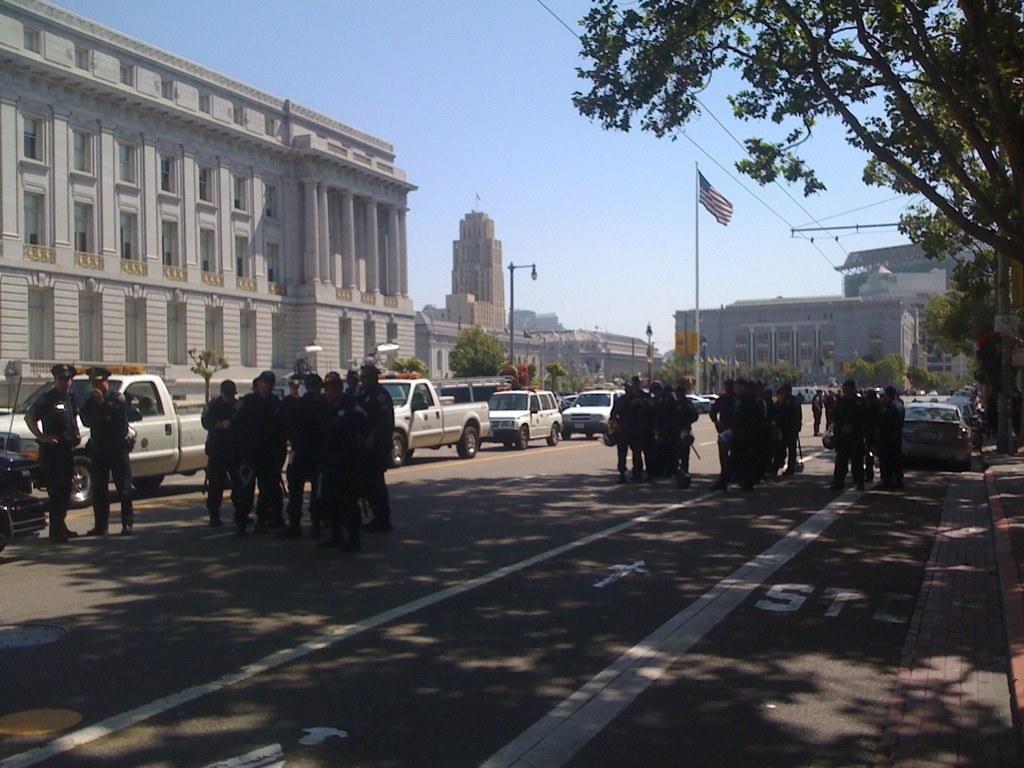Could you give a brief overview of what you see in this image? In this image there are group of people who are holding flag and walking, and in the background there are some vehicles, trees, poles, buildings, street lights and some wires. At the bottom there is a walkway and at the top there is sky. 